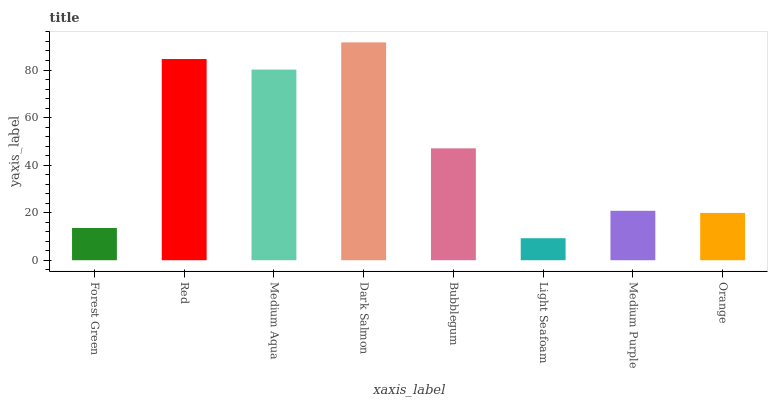Is Light Seafoam the minimum?
Answer yes or no. Yes. Is Dark Salmon the maximum?
Answer yes or no. Yes. Is Red the minimum?
Answer yes or no. No. Is Red the maximum?
Answer yes or no. No. Is Red greater than Forest Green?
Answer yes or no. Yes. Is Forest Green less than Red?
Answer yes or no. Yes. Is Forest Green greater than Red?
Answer yes or no. No. Is Red less than Forest Green?
Answer yes or no. No. Is Bubblegum the high median?
Answer yes or no. Yes. Is Medium Purple the low median?
Answer yes or no. Yes. Is Medium Purple the high median?
Answer yes or no. No. Is Bubblegum the low median?
Answer yes or no. No. 